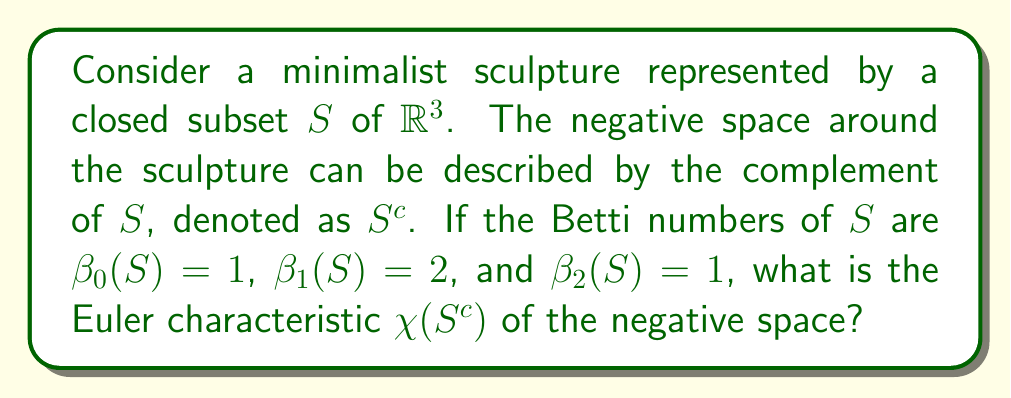Can you solve this math problem? To solve this problem, we'll follow these steps:

1) First, recall the definition of Euler characteristic for a topological space $X$:

   $$\chi(X) = \sum_{i=0}^{\infty} (-1)^i \beta_i(X)$$

   where $\beta_i(X)$ are the Betti numbers of $X$.

2) For the sculpture $S$, we're given:
   $\beta_0(S) = 1$ (one connected component)
   $\beta_1(S) = 2$ (two "holes" or tunnels)
   $\beta_2(S) = 1$ (one enclosed void)

3) Calculate $\chi(S)$:

   $$\chi(S) = \beta_0(S) - \beta_1(S) + \beta_2(S) = 1 - 2 + 1 = 0$$

4) Now, we can use Alexander duality, which relates the homology of a subspace of $S^3$ to the homology of its complement. For a compact subset $K$ of $S^3$, Alexander duality states:

   $$\tilde{H}_i(S^3 - K) \cong \tilde{H}_{2-i}(K)$$

   where $\tilde{H}_i$ denotes reduced homology.

5) This implies that the Betti numbers of $S^c$ (excluding $\beta_0$) are related to those of $S$ as follows:

   $\beta_1(S^c) = \beta_1(S) = 2$
   $\beta_2(S^c) = \beta_0(S) - 1 = 0$

6) For $\beta_0(S^c)$, note that $S^c$ is connected (as $S$ is compact), so $\beta_0(S^c) = 1$.

7) Now we can calculate $\chi(S^c)$:

   $$\chi(S^c) = \beta_0(S^c) - \beta_1(S^c) + \beta_2(S^c) = 1 - 2 + 0 = -1$$

Thus, the Euler characteristic of the negative space is -1.
Answer: $\chi(S^c) = -1$ 